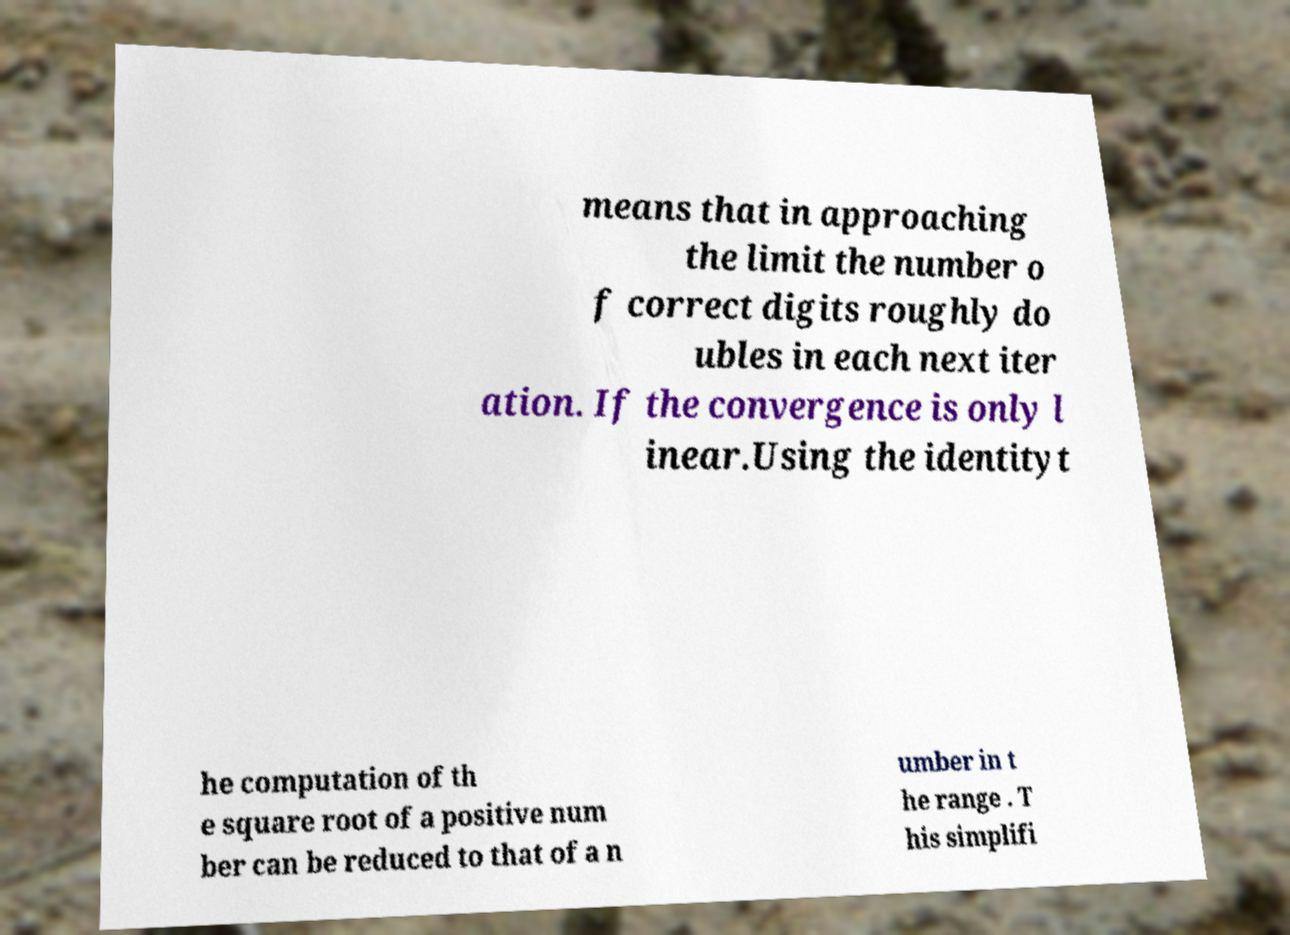I need the written content from this picture converted into text. Can you do that? means that in approaching the limit the number o f correct digits roughly do ubles in each next iter ation. If the convergence is only l inear.Using the identityt he computation of th e square root of a positive num ber can be reduced to that of a n umber in t he range . T his simplifi 